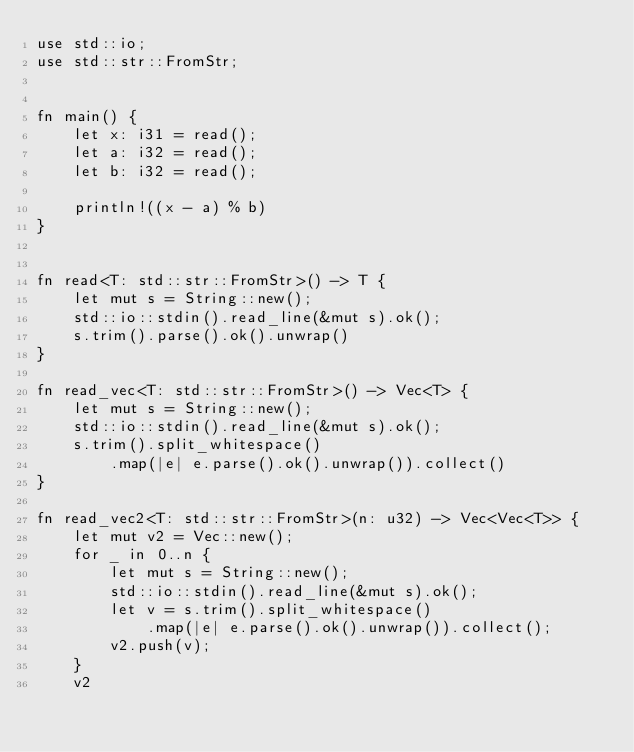<code> <loc_0><loc_0><loc_500><loc_500><_Rust_>use std::io;
use std::str::FromStr;


fn main() {
    let x: i31 = read();
    let a: i32 = read();
    let b: i32 = read();

    println!((x - a) % b)
}


fn read<T: std::str::FromStr>() -> T {
    let mut s = String::new();
    std::io::stdin().read_line(&mut s).ok();
    s.trim().parse().ok().unwrap()
}

fn read_vec<T: std::str::FromStr>() -> Vec<T> {
    let mut s = String::new();
    std::io::stdin().read_line(&mut s).ok();
    s.trim().split_whitespace()
        .map(|e| e.parse().ok().unwrap()).collect()
}

fn read_vec2<T: std::str::FromStr>(n: u32) -> Vec<Vec<T>> {
    let mut v2 = Vec::new();
    for _ in 0..n {
        let mut s = String::new();
        std::io::stdin().read_line(&mut s).ok();
        let v = s.trim().split_whitespace()
            .map(|e| e.parse().ok().unwrap()).collect();
        v2.push(v);
    }
    v2
</code> 